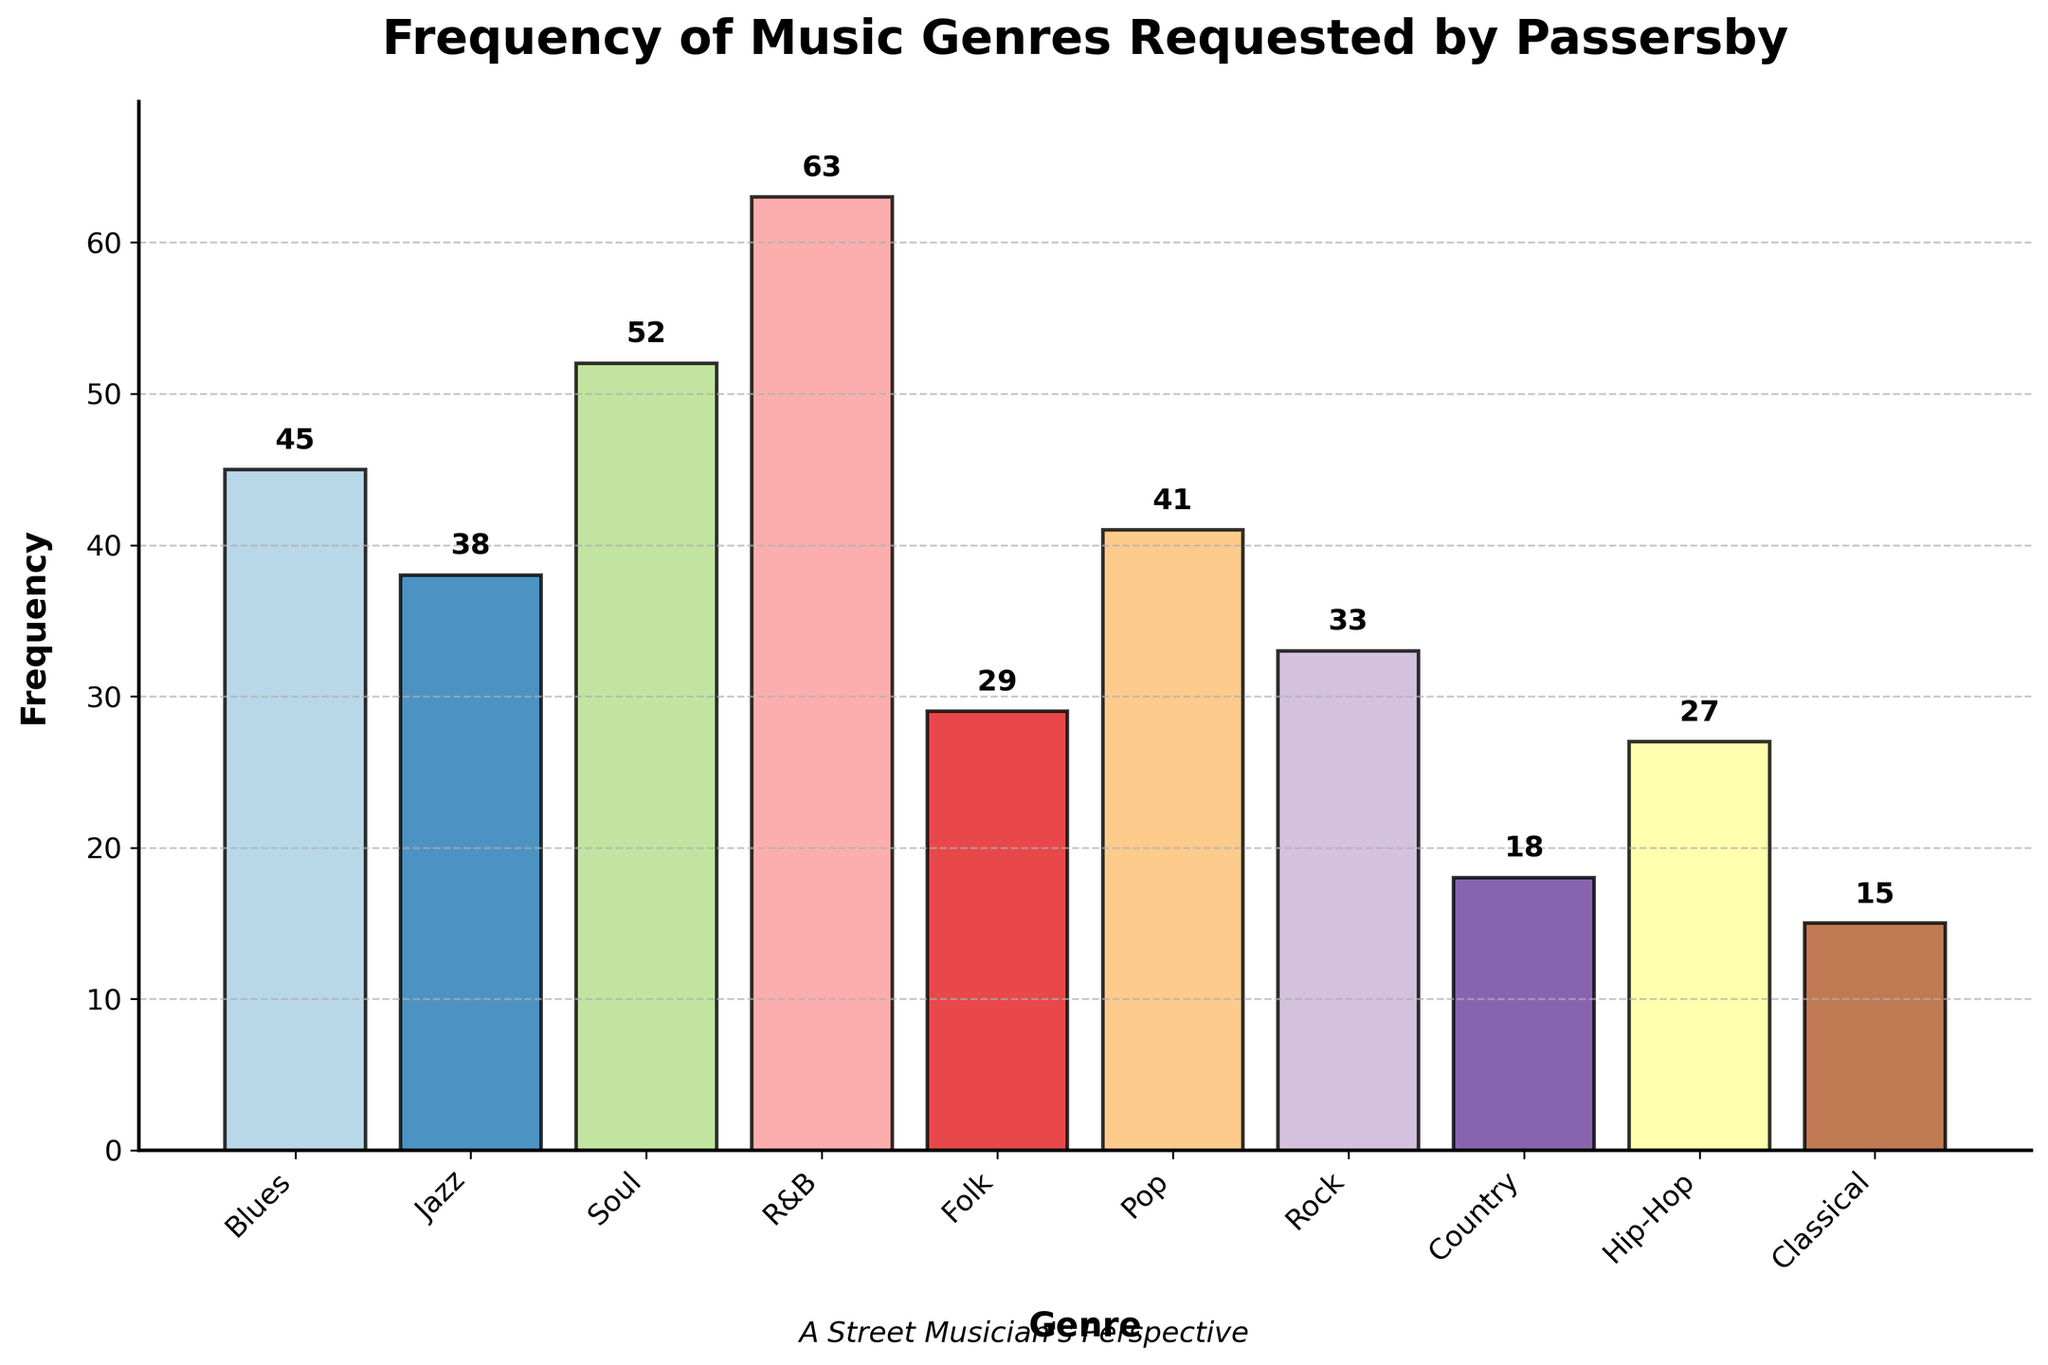Which genre has the highest frequency? By looking at the height of the bars in the histogram, the tallest bar represents the genre with the highest frequency. The R&B genre has the highest bar.
Answer: R&B What's the total frequency of Soul and Pop requests combined? To find the total frequency of the Soul and Pop genres, we need to sum their individual frequencies. Soul has 52 requests, and Pop has 41 requests, so 52 + 41 = 93.
Answer: 93 Which genres have a frequency greater than 40? By identifying the bars in the histogram that surpass the 40 mark on the y-axis, we can see that Blues, Soul, R&B, and Pop all have frequencies greater than 40.
Answer: Blues, Soul, R&B, Pop What is the difference in frequency between Jazz and Country genres? To determine the difference in frequency between Jazz and Country, we subtract the frequency of Country (18) from Jazz (38), resulting in a difference of 20.
Answer: 20 How many genres have a frequency less than 30? Counting the bars that do not reach the 30 mark on the y-axis, we find that there are five genres: Folk, Country, Hip-Hop, and Classical.
Answer: 4 Which genre has the lowest frequency? By identifying the shortest bar in the histogram, we find that the Classical genre has the lowest frequency.
Answer: Classical What is the average frequency of all the genres? To find the average frequency, we need to sum all the frequencies and divide by the number of genres. The total frequency is 45+38+52+63+29+41+33+18+27+15 = 361, and there are 10 genres, so the average is 361 / 10 = 36.1.
Answer: 36.1 What is the median frequency of the genres? To find the median frequency, we need to list the frequencies in ascending order and find the middle value. The sorted frequencies are 15, 18, 27, 29, 33, 38, 41, 45, 52, 63. With an even number of data points, the median is the average of the 5th and 6th values, (33 + 38) / 2 = 35.5.
Answer: 35.5 Which genre is requested more: Folk or Rock? By comparing the heights of the bars for Folk and Rock genres, we see that Rock (33) is higher than Folk (29).
Answer: Rock 